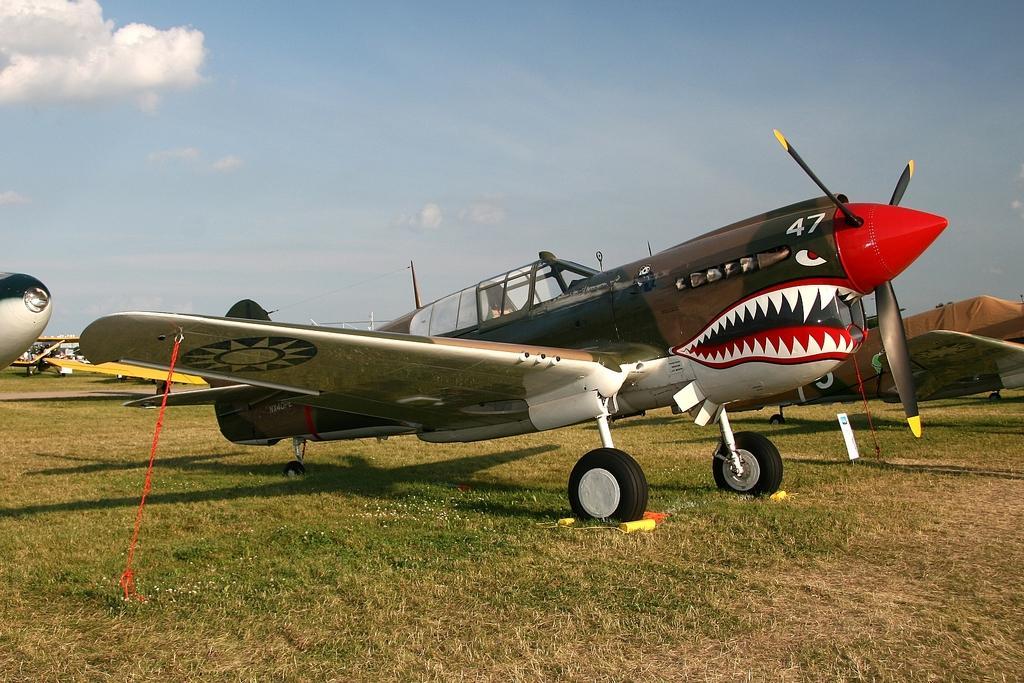How would you summarize this image in a sentence or two? In this image there are airplanes on a ground in the background there is the sky. 